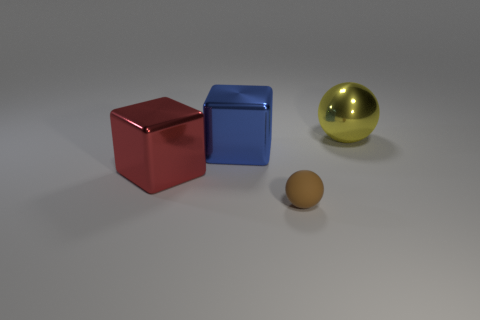Add 4 large yellow shiny cubes. How many objects exist? 8 Add 4 brown rubber balls. How many brown rubber balls exist? 5 Subtract 0 brown cylinders. How many objects are left? 4 Subtract all brown objects. Subtract all yellow objects. How many objects are left? 2 Add 3 large red metallic objects. How many large red metallic objects are left? 4 